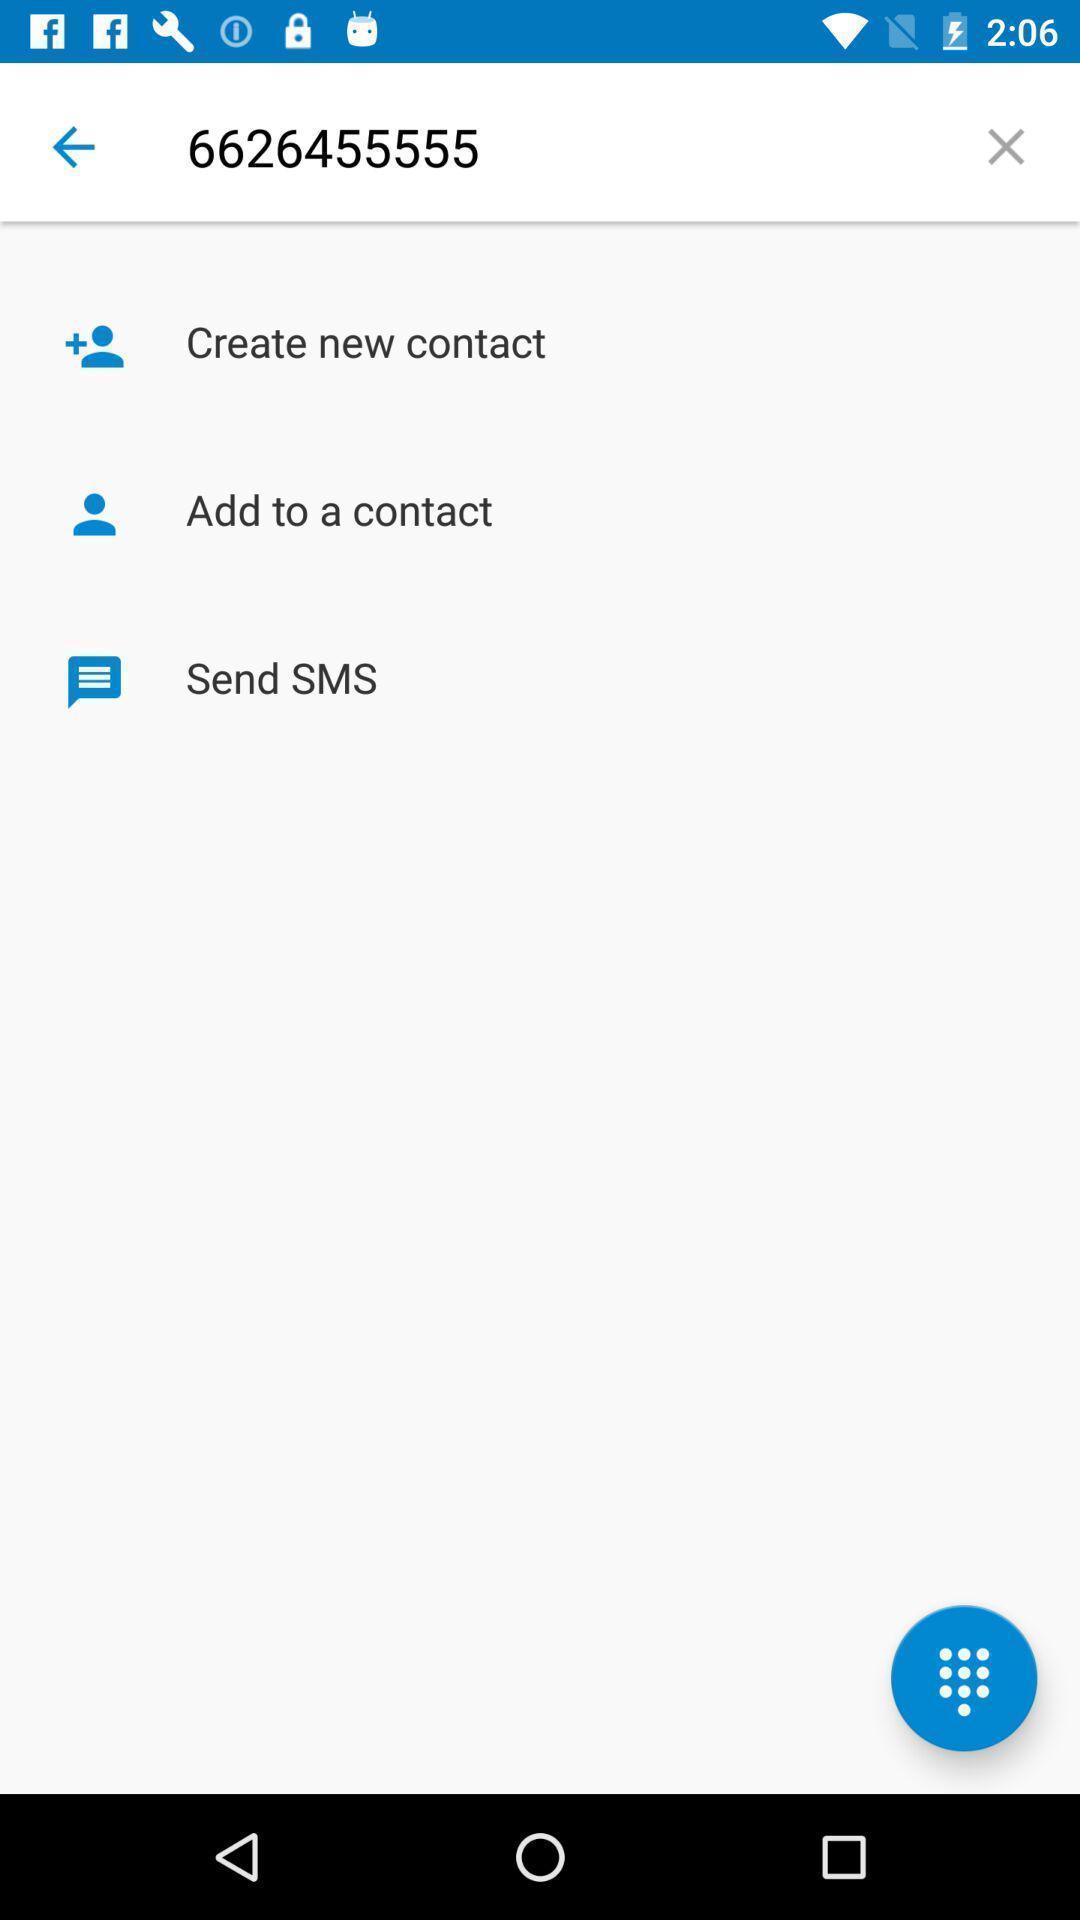What can you discern from this picture? Page showing different options for saving contact. 